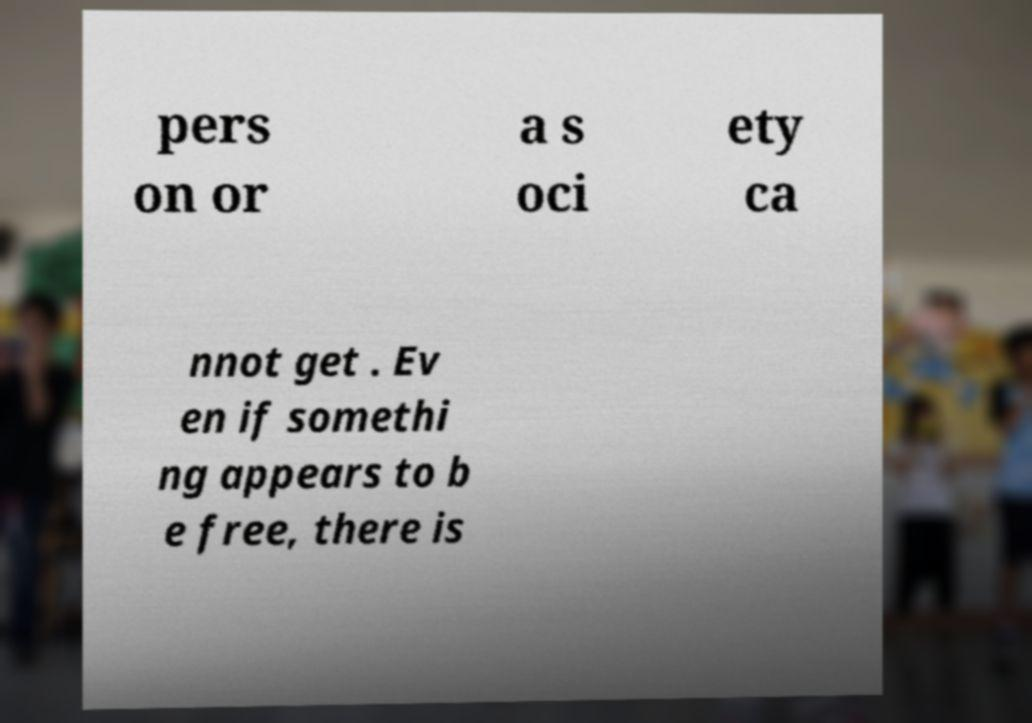Please read and relay the text visible in this image. What does it say? pers on or a s oci ety ca nnot get . Ev en if somethi ng appears to b e free, there is 